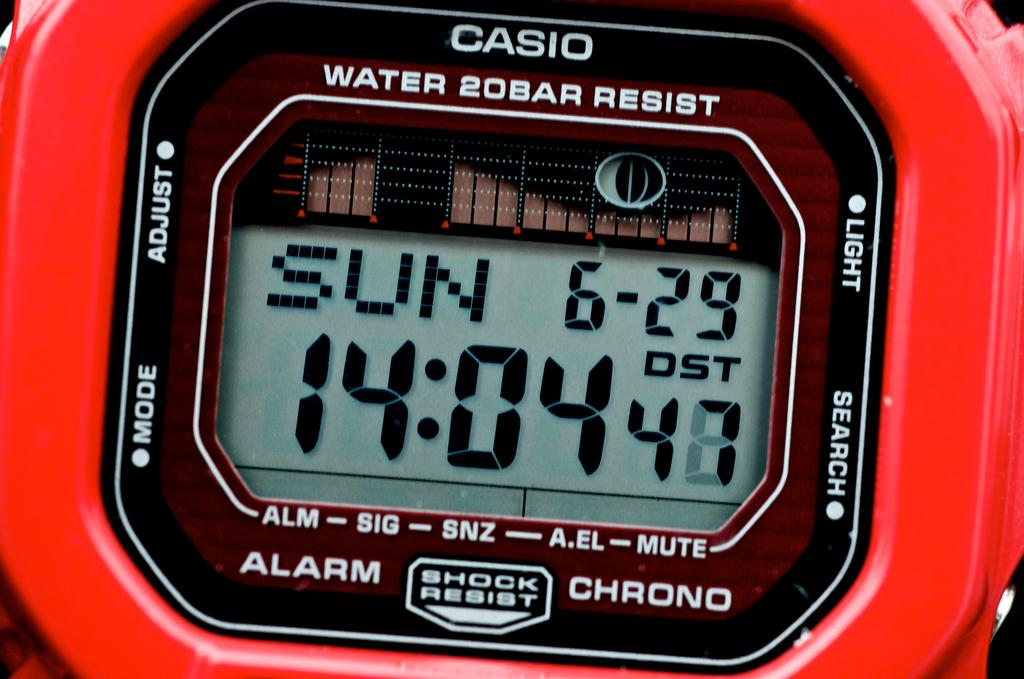<image>
Present a compact description of the photo's key features. a red CASIO watch with Shock Resist in a close up 